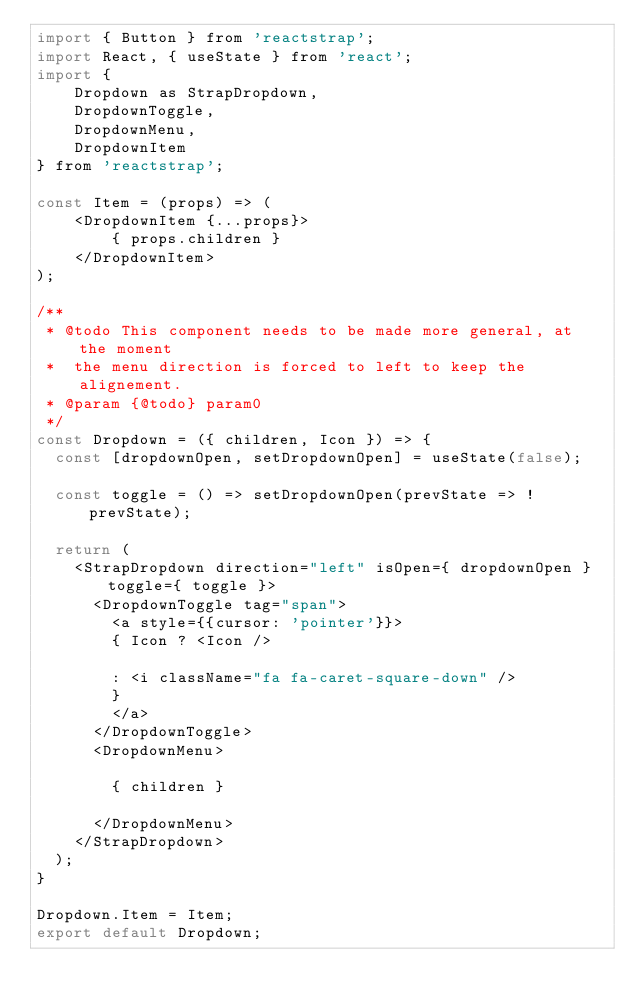Convert code to text. <code><loc_0><loc_0><loc_500><loc_500><_JavaScript_>import { Button } from 'reactstrap';
import React, { useState } from 'react';
import { 
    Dropdown as StrapDropdown, 
    DropdownToggle, 
    DropdownMenu, 
    DropdownItem 
} from 'reactstrap';

const Item = (props) => (
    <DropdownItem {...props}>
        { props.children }
    </DropdownItem>
);

/**
 * @todo This component needs to be made more general, at the moment
 *  the menu direction is forced to left to keep the alignement. 
 * @param {@todo} param0 
 */
const Dropdown = ({ children, Icon }) => {
  const [dropdownOpen, setDropdownOpen] = useState(false);

  const toggle = () => setDropdownOpen(prevState => !prevState);

  return (
    <StrapDropdown direction="left" isOpen={ dropdownOpen } toggle={ toggle }>
      <DropdownToggle tag="span">  
        <a style={{cursor: 'pointer'}}>
        { Icon ? <Icon />
        
        : <i className="fa fa-caret-square-down" />
        }
        </a>
      </DropdownToggle>
      <DropdownMenu>
     
        { children }
     
      </DropdownMenu>
    </StrapDropdown>
  );
}

Dropdown.Item = Item;
export default Dropdown;
</code> 